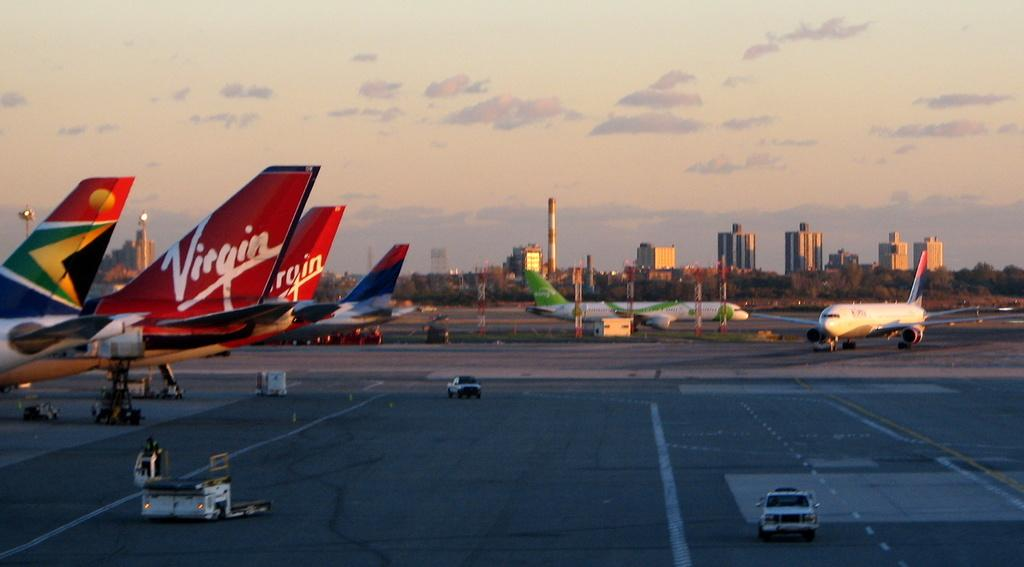What can be seen on the runway in the image? There are airplanes and vehicles on the runway in the image. What else is visible in the image besides the runway? There are buildings, trees, and the sky visible in the image. Can you describe the sky in the image? The sky is visible in the background of the image. What type of paper is being used to plough the field in the image? There is no paper or ploughing activity present in the image. 